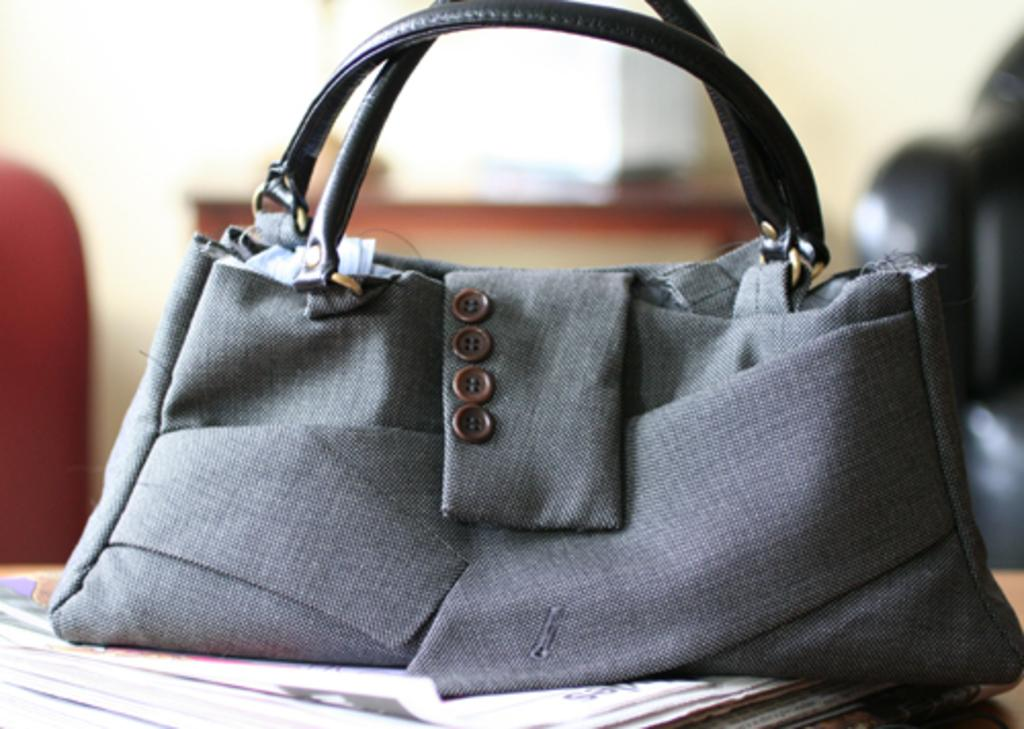What is the main subject of the image? The main subject of the image is a bag made of suit. What can be observed about the handles of the bag? The bag has black handles. What is the bag placed on in the image? The bag is placed on papers. What is visible behind the bag in the image? There is a table behind the bag. Can you see a rat eating soup with a fork in the image? No, there is no rat, soup, or fork present in the image. 